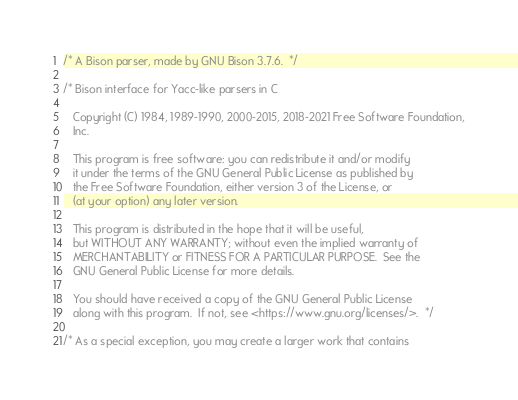<code> <loc_0><loc_0><loc_500><loc_500><_C_>/* A Bison parser, made by GNU Bison 3.7.6.  */

/* Bison interface for Yacc-like parsers in C

   Copyright (C) 1984, 1989-1990, 2000-2015, 2018-2021 Free Software Foundation,
   Inc.

   This program is free software: you can redistribute it and/or modify
   it under the terms of the GNU General Public License as published by
   the Free Software Foundation, either version 3 of the License, or
   (at your option) any later version.

   This program is distributed in the hope that it will be useful,
   but WITHOUT ANY WARRANTY; without even the implied warranty of
   MERCHANTABILITY or FITNESS FOR A PARTICULAR PURPOSE.  See the
   GNU General Public License for more details.

   You should have received a copy of the GNU General Public License
   along with this program.  If not, see <https://www.gnu.org/licenses/>.  */

/* As a special exception, you may create a larger work that contains</code> 